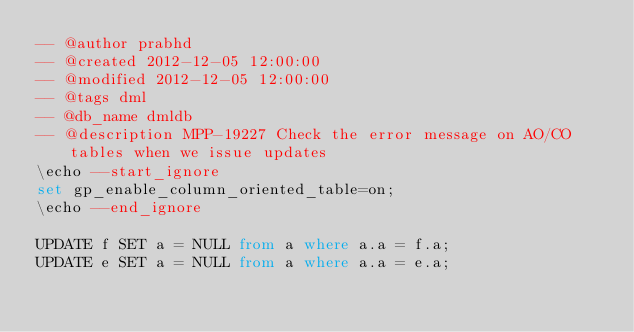Convert code to text. <code><loc_0><loc_0><loc_500><loc_500><_SQL_>-- @author prabhd 
-- @created 2012-12-05 12:00:00 
-- @modified 2012-12-05 12:00:00 
-- @tags dml 
-- @db_name dmldb
-- @description MPP-19227 Check the error message on AO/CO tables when we issue updates
\echo --start_ignore
set gp_enable_column_oriented_table=on;
\echo --end_ignore

UPDATE f SET a = NULL from a where a.a = f.a;
UPDATE e SET a = NULL from a where a.a = e.a;
</code> 